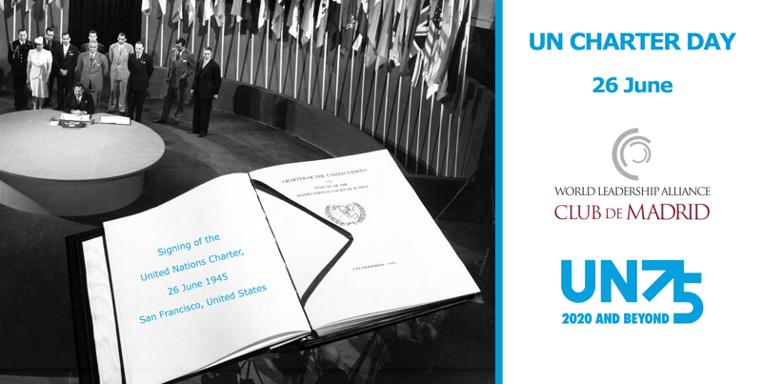Can you tell me more about the historical context depicted in the black and white photo portion of the image? The black and white photo in the image captures a moment from the signing ceremony of the United Nations Charter in 1945. It shows delegates from around the world who gathered in San Francisco to sign this foundational document of the United Nations, marking the end of the United Nations Conference on International Organization and formalizing the establishment of the UN. What relevance does the UN Charter have in today's world? The UN Charter remains a cornerstone of international law and global governance. Today, it serves as a guiding framework for the actions of the United Nations and its member states in their collective efforts to manage conflicts, address humanitarian crises, foster sustainable development, protect human rights, and uphold international peace and security. 